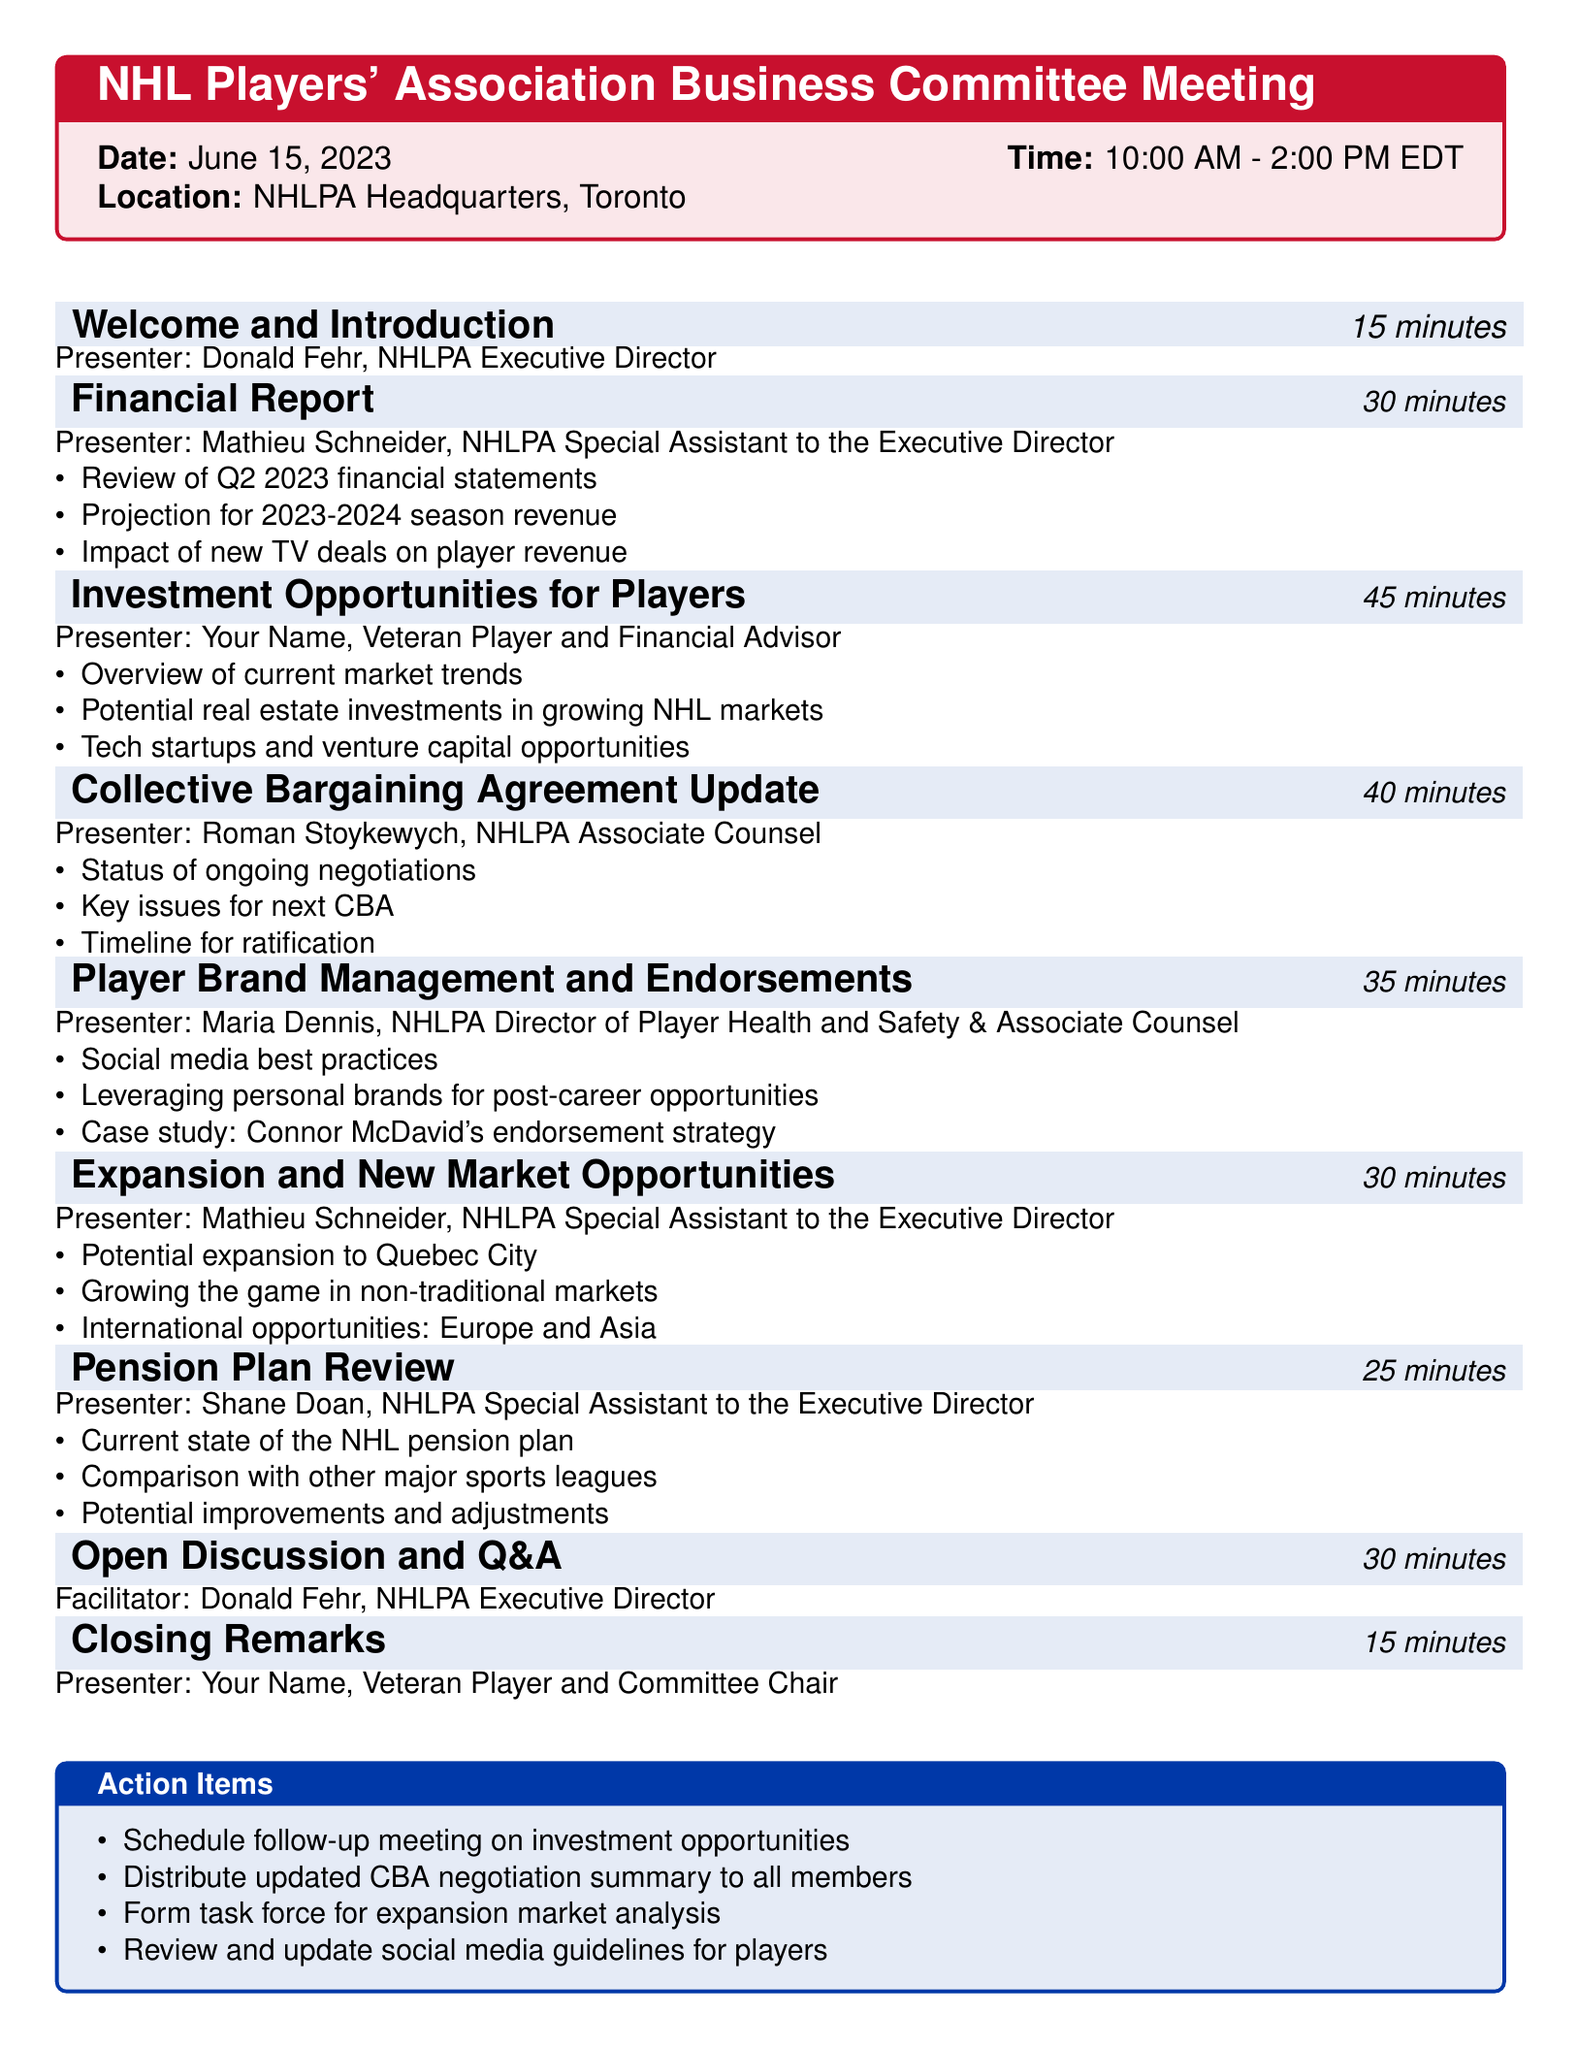What is the date of the meeting? The date of the meeting is explicitly stated in the meeting details section of the document.
Answer: June 15, 2023 Who is the presenter for the Financial Report? The presenter's name is mentioned under the Financial Report agenda item.
Answer: Mathieu Schneider How long is the Investment Opportunities for Players discussion? The duration is specified in the agenda item for this discussion.
Answer: 45 minutes What are the key issues for the next CBA? The specific key issues are detailed under the Collective Bargaining Agreement Update agenda item.
Answer: Not specified in the document How many action items are listed in total? The action items are listed at the end of the agenda, and they can be counted.
Answer: 4 Who will facilitate the Open Discussion and Q&A? The facilitator's name is provided in the agenda for this segment.
Answer: Donald Fehr What is one potential new market mentioned for NHL expansion? The document lists potential expansion locations in the discussion on new market opportunities.
Answer: Quebec City What is the duration of the Closing Remarks? The length of the Closing Remarks is given in the agenda.
Answer: 15 minutes 